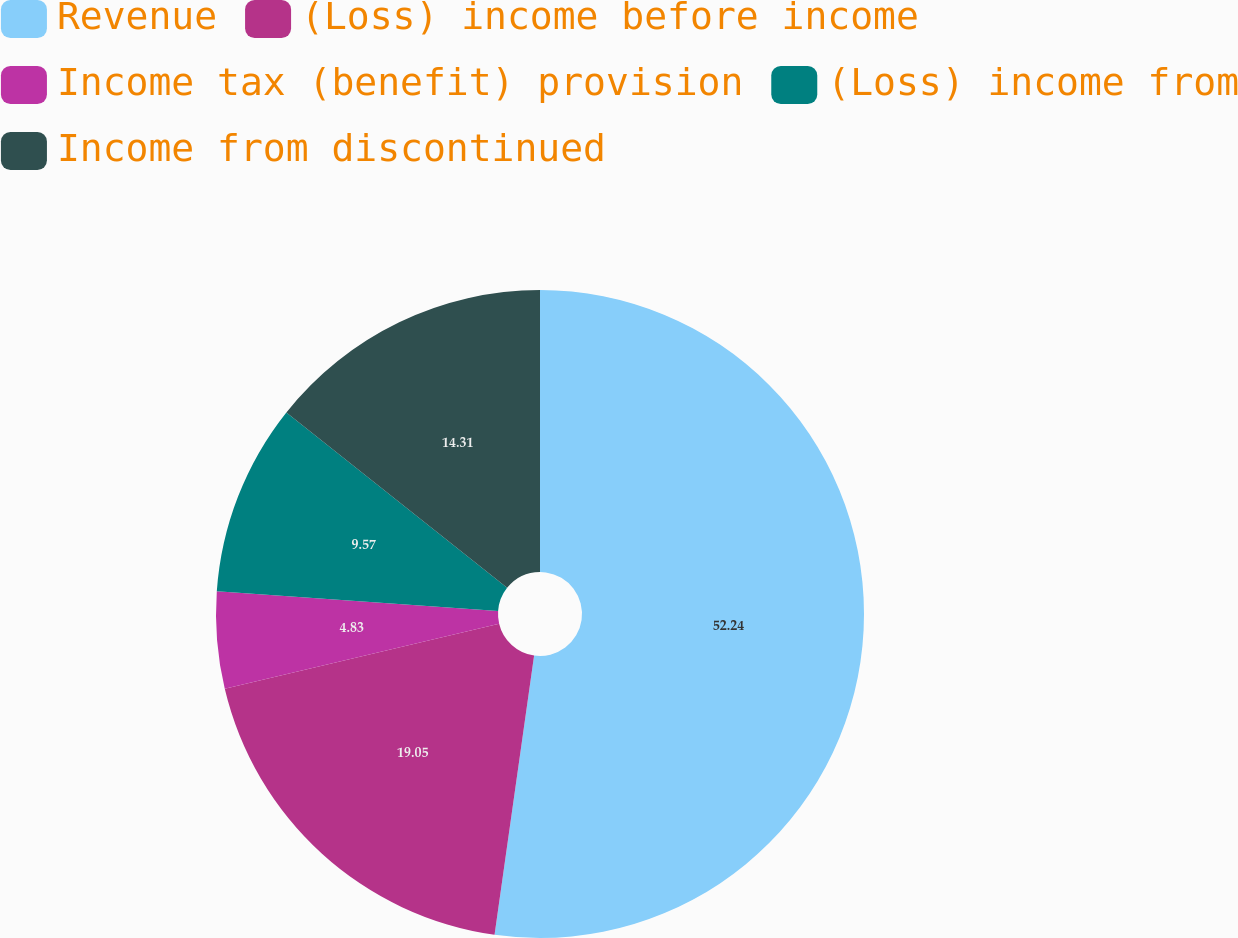<chart> <loc_0><loc_0><loc_500><loc_500><pie_chart><fcel>Revenue<fcel>(Loss) income before income<fcel>Income tax (benefit) provision<fcel>(Loss) income from<fcel>Income from discontinued<nl><fcel>52.24%<fcel>19.05%<fcel>4.83%<fcel>9.57%<fcel>14.31%<nl></chart> 